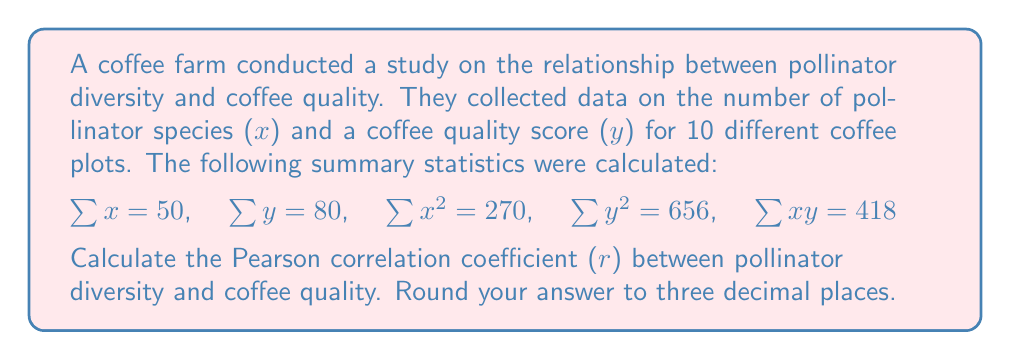Provide a solution to this math problem. To calculate the Pearson correlation coefficient (r), we'll use the formula:

$$r = \frac{n\sum xy - \sum x \sum y}{\sqrt{[n\sum x^2 - (\sum x)^2][n\sum y^2 - (\sum y)^2]}}$$

Where n is the number of data points (10 in this case).

Step 1: Calculate $n\sum xy$
$n\sum xy = 10 \times 418 = 4180$

Step 2: Calculate $\sum x \sum y$
$\sum x \sum y = 50 \times 80 = 4000$

Step 3: Calculate the numerator
$n\sum xy - \sum x \sum y = 4180 - 4000 = 180$

Step 4: Calculate $n\sum x^2$ and $(\sum x)^2$
$n\sum x^2 = 10 \times 270 = 2700$
$(\sum x)^2 = 50^2 = 2500$

Step 5: Calculate $n\sum y^2$ and $(\sum y)^2$
$n\sum y^2 = 10 \times 656 = 6560$
$(\sum y)^2 = 80^2 = 6400$

Step 6: Calculate the denominator
$\sqrt{[n\sum x^2 - (\sum x)^2][n\sum y^2 - (\sum y)^2]}$
$= \sqrt{(2700 - 2500)(6560 - 6400)}$
$= \sqrt{200 \times 160}$
$= \sqrt{32000}$
$= 178.885$

Step 7: Calculate r
$r = \frac{180}{178.885} = 1.006$

Step 8: Round to three decimal places
$r = 1.006 \approx 1.006$
Answer: 1.006 